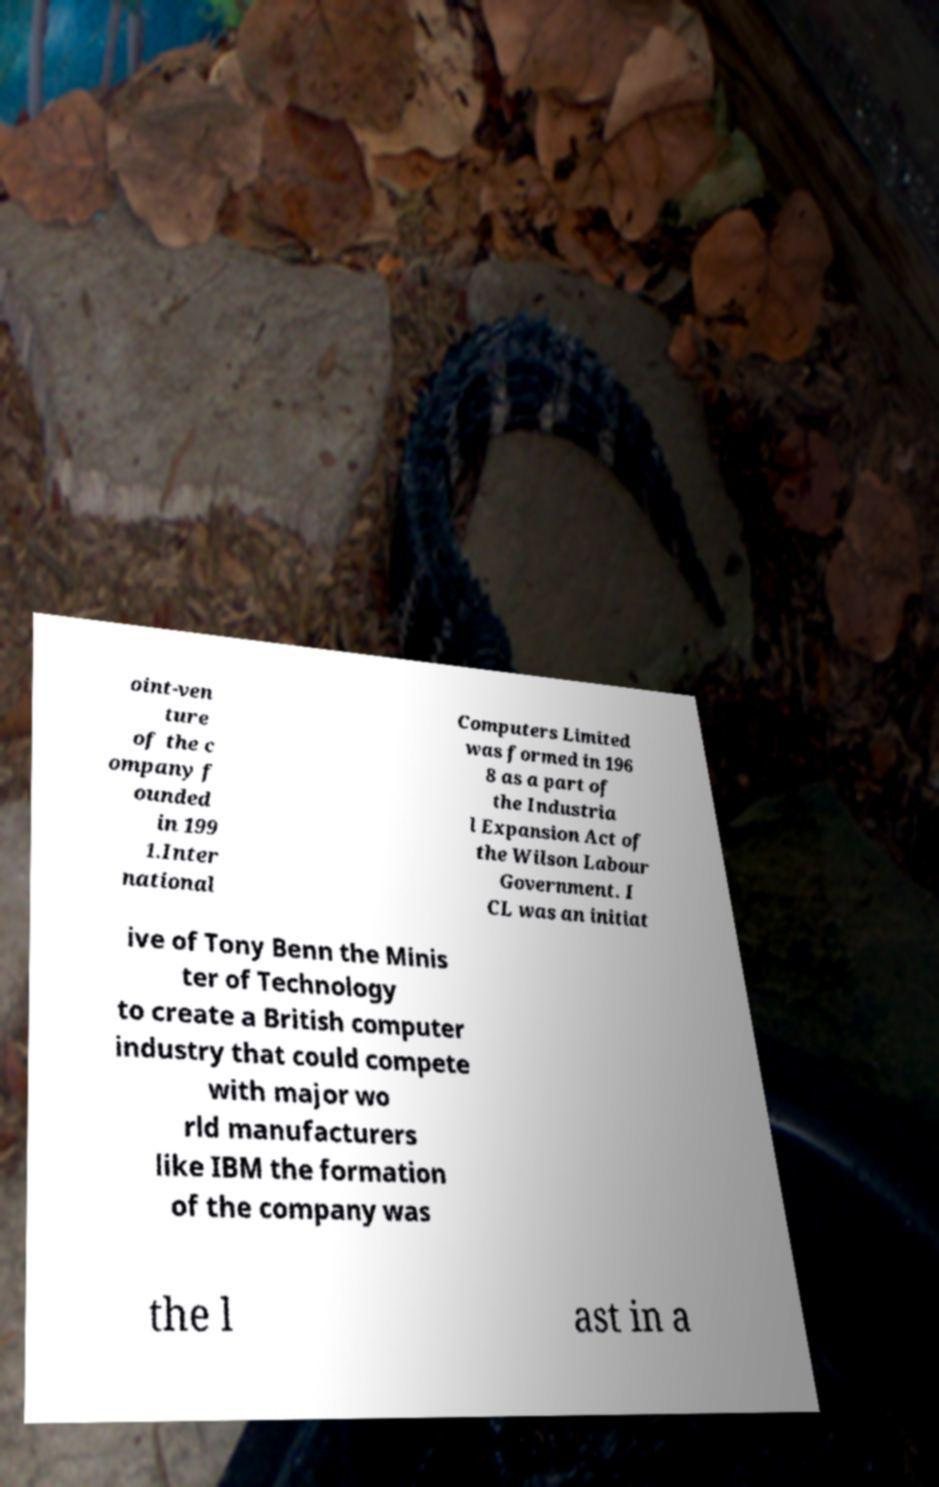Could you assist in decoding the text presented in this image and type it out clearly? oint-ven ture of the c ompany f ounded in 199 1.Inter national Computers Limited was formed in 196 8 as a part of the Industria l Expansion Act of the Wilson Labour Government. I CL was an initiat ive of Tony Benn the Minis ter of Technology to create a British computer industry that could compete with major wo rld manufacturers like IBM the formation of the company was the l ast in a 